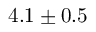<formula> <loc_0><loc_0><loc_500><loc_500>4 . 1 \pm 0 . 5</formula> 